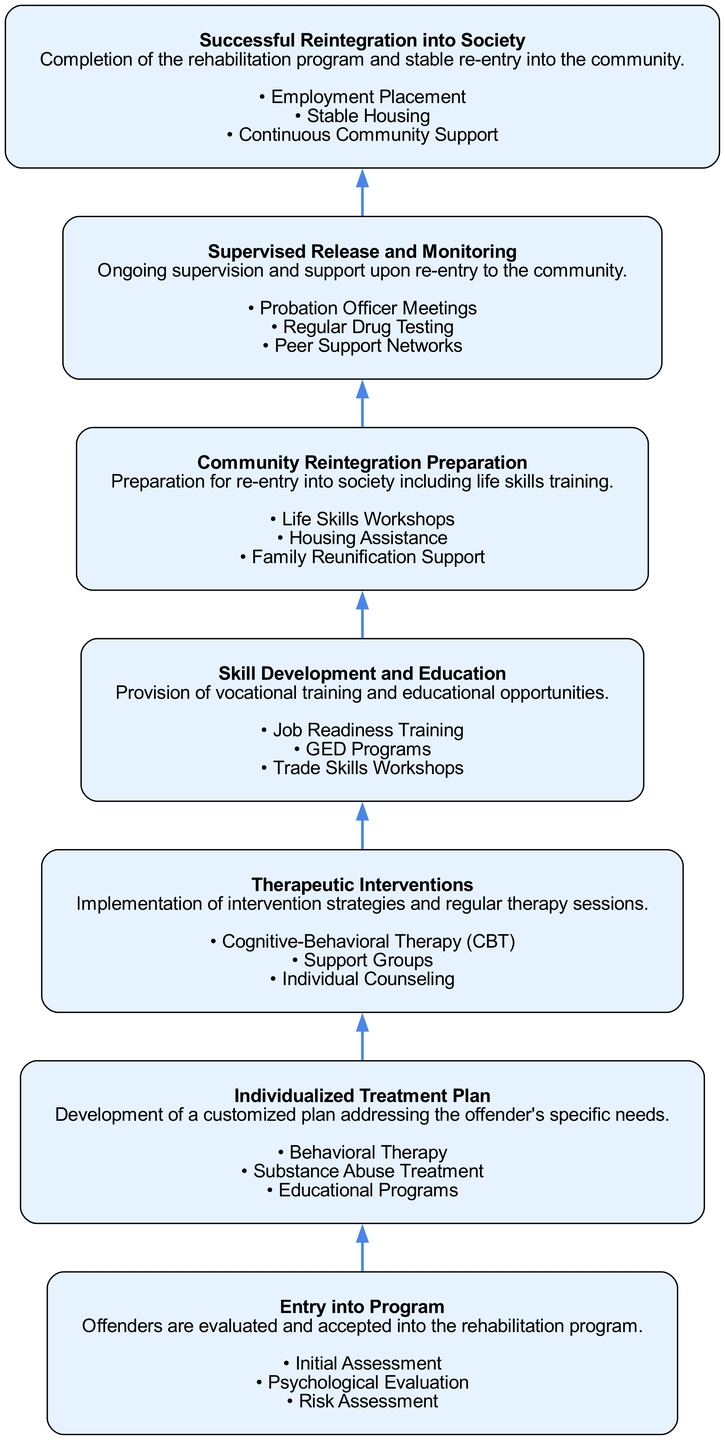What is the first stage in the flow chart? The first stage, which is positioned at the bottom of the diagram, is labeled "Entry into Program". This is evident as it's listed before any other stages.
Answer: Entry into Program How many key components are there in the "Individualized Treatment Plan"? In the stage "Individualized Treatment Plan", there are three specified key components: Behavioral Therapy, Substance Abuse Treatment, and Educational Programs. Thus, the number of key components is three.
Answer: 3 What stage follows "Skill Development and Education"? The stage that follows "Skill Development and Education" is "Community Reintegration Preparation". The flow of the diagram clearly indicates the order of the stages, showing this direct connection.
Answer: Community Reintegration Preparation Which stage involves "Regular Drug Testing"? "Supervised Release and Monitoring" includes "Regular Drug Testing" as one of its key components, according to its description in the flow chart. This is derived from the key components listed under that stage.
Answer: Supervised Release and Monitoring What is the last stage before successful reintegration? The stage that comes immediately before "Successful Reintegration into Society" is "Supervised Release and Monitoring". It is the last step before achieving successful reintegration, as per the sequential flow.
Answer: Supervised Release and Monitoring How does "Skill Development and Education" contribute to the program? "Skill Development and Education" aids in the program by providing vocational training and educational opportunities, which are vital for the offender's ability to gain stable employment and reintegrate successfully.
Answer: Vocational training and educational opportunities What is one key component of "Community Reintegration Preparation"? One key component of the "Community Reintegration Preparation" stage is "Life Skills Workshops," which is crucial for preparing offenders for daily challenges after re-entering society. This can be found in the list of components for that stage.
Answer: Life Skills Workshops What is the overall objective of the flow chart? The overall objective of the flow chart is to illustrate the process leading to "Successful Reintegration into Society" for offenders, highlighting the necessary stages and components that support their rehabilitation journey.
Answer: Successful Reintegration into Society 